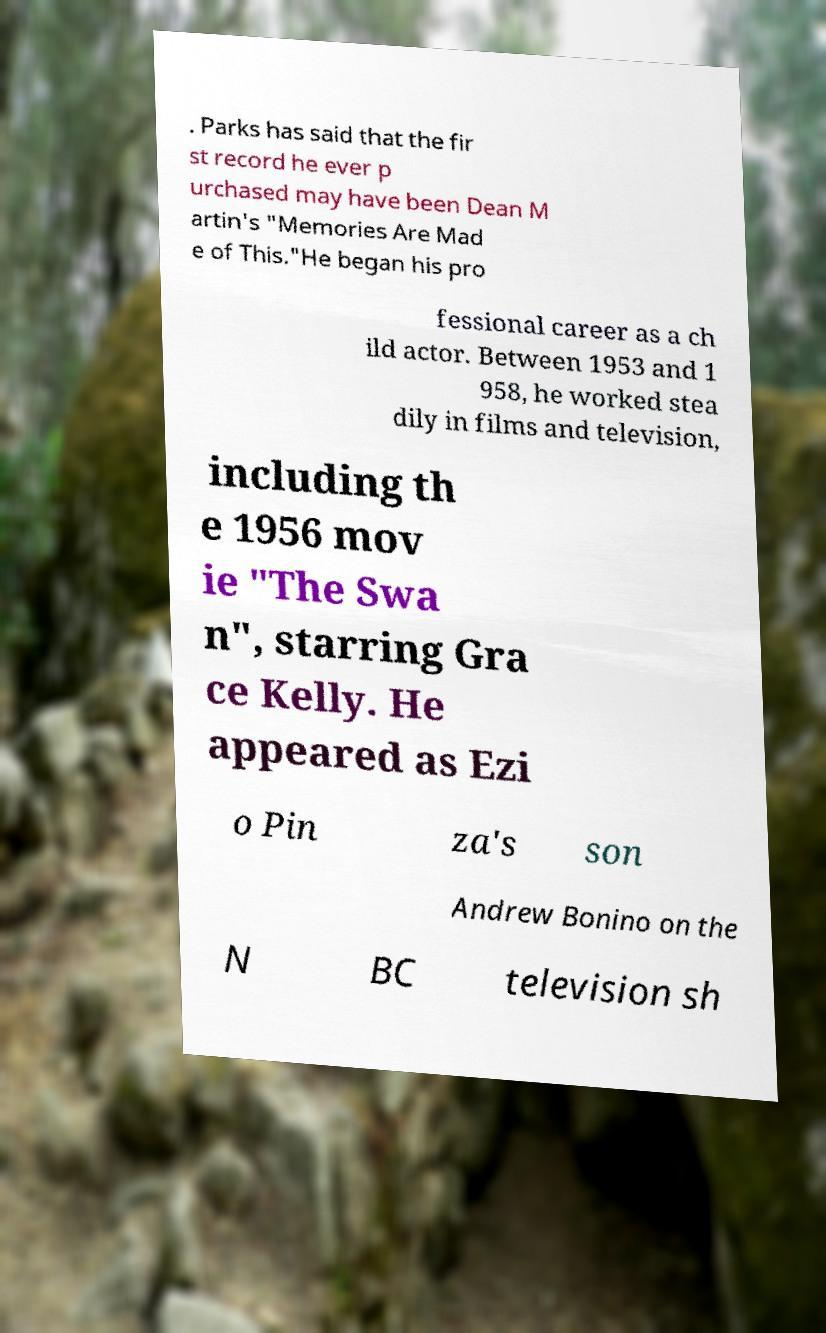There's text embedded in this image that I need extracted. Can you transcribe it verbatim? . Parks has said that the fir st record he ever p urchased may have been Dean M artin's "Memories Are Mad e of This."He began his pro fessional career as a ch ild actor. Between 1953 and 1 958, he worked stea dily in films and television, including th e 1956 mov ie "The Swa n", starring Gra ce Kelly. He appeared as Ezi o Pin za's son Andrew Bonino on the N BC television sh 